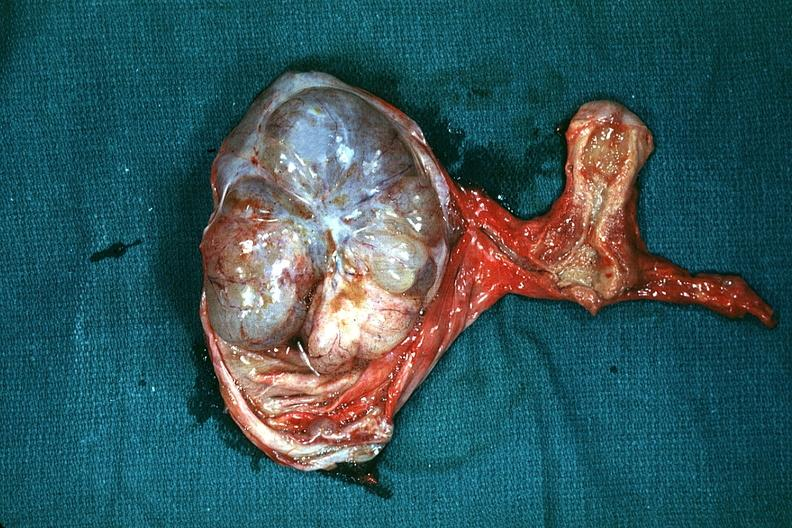what is present?
Answer the question using a single word or phrase. Female reproductive 